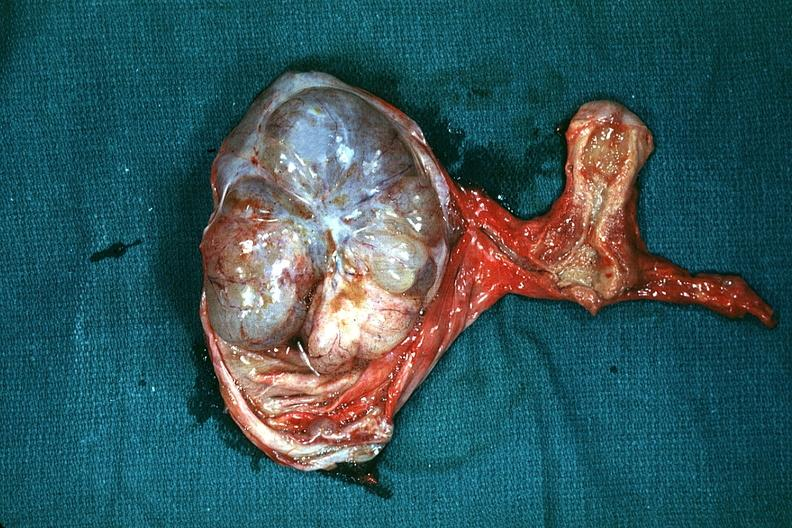what is present?
Answer the question using a single word or phrase. Female reproductive 